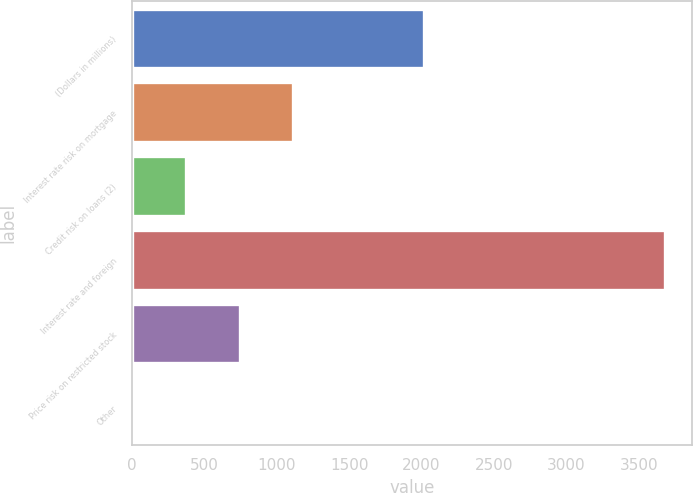Convert chart to OTSL. <chart><loc_0><loc_0><loc_500><loc_500><bar_chart><fcel>(Dollars in millions)<fcel>Interest rate risk on mortgage<fcel>Credit risk on loans (2)<fcel>Interest rate and foreign<fcel>Price risk on restricted stock<fcel>Other<nl><fcel>2014<fcel>1111.2<fcel>376.4<fcel>3683<fcel>743.8<fcel>9<nl></chart> 